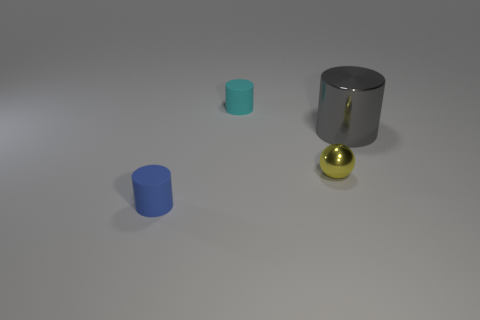What number of tiny cylinders are behind the object to the right of the yellow thing?
Provide a succinct answer. 1. How many things are either tiny blue shiny cylinders or yellow objects?
Your response must be concise. 1. Do the tiny yellow object and the small cyan rubber object have the same shape?
Make the answer very short. No. What is the big cylinder made of?
Keep it short and to the point. Metal. What number of cylinders are both right of the small yellow metal object and to the left of the metallic sphere?
Your response must be concise. 0. Is the size of the gray object the same as the yellow thing?
Your answer should be very brief. No. There is a rubber cylinder in front of the yellow thing; is it the same size as the big cylinder?
Make the answer very short. No. What is the color of the rubber thing behind the yellow object?
Your response must be concise. Cyan. What number of green metallic cylinders are there?
Offer a terse response. 0. The thing that is made of the same material as the cyan cylinder is what shape?
Ensure brevity in your answer.  Cylinder. 